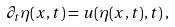<formula> <loc_0><loc_0><loc_500><loc_500>\partial _ { t } \eta ( x , t ) = u ( \eta ( x , t ) , t ) \, ,</formula> 